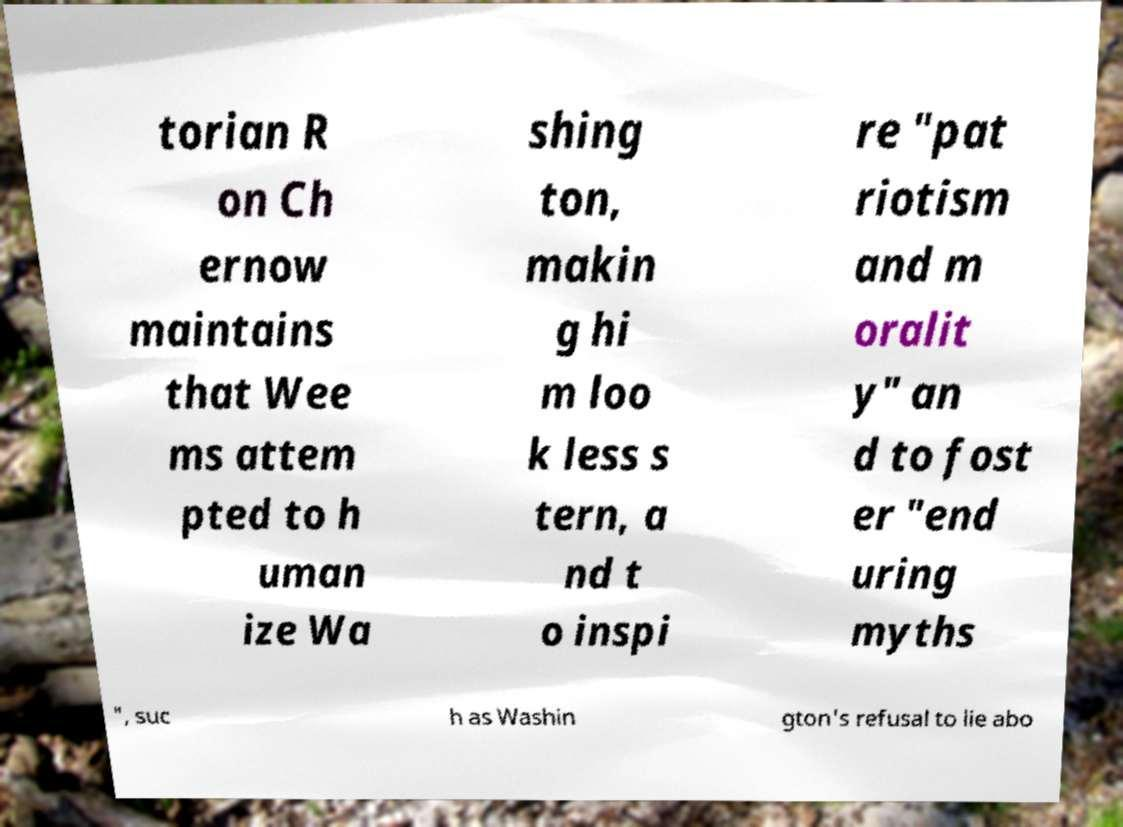Can you read and provide the text displayed in the image?This photo seems to have some interesting text. Can you extract and type it out for me? torian R on Ch ernow maintains that Wee ms attem pted to h uman ize Wa shing ton, makin g hi m loo k less s tern, a nd t o inspi re "pat riotism and m oralit y" an d to fost er "end uring myths ", suc h as Washin gton's refusal to lie abo 